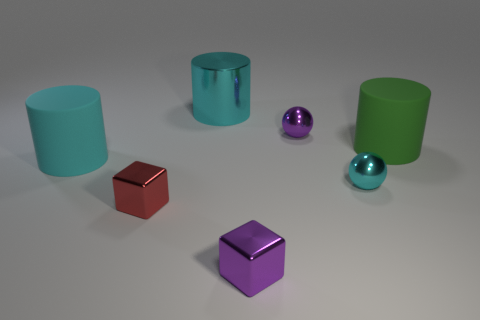What number of shiny objects are cyan cylinders or cyan objects?
Offer a terse response. 2. Is the number of blocks that are in front of the small red metallic thing greater than the number of big green matte cylinders?
Make the answer very short. No. What number of other objects are there of the same material as the green cylinder?
Your answer should be very brief. 1. How many tiny objects are purple shiny objects or red things?
Your answer should be very brief. 3. Does the large green cylinder have the same material as the small red block?
Offer a very short reply. No. How many large green things are behind the cyan thing that is behind the large cyan rubber cylinder?
Offer a very short reply. 0. Is there a big green rubber thing that has the same shape as the big cyan matte object?
Your response must be concise. Yes. Do the small purple metallic object that is in front of the green thing and the tiny metal thing on the right side of the purple sphere have the same shape?
Offer a very short reply. No. What shape is the cyan object that is both on the left side of the purple metallic ball and in front of the big green rubber object?
Provide a short and direct response. Cylinder. Are there any green rubber things that have the same size as the red cube?
Offer a terse response. No. 